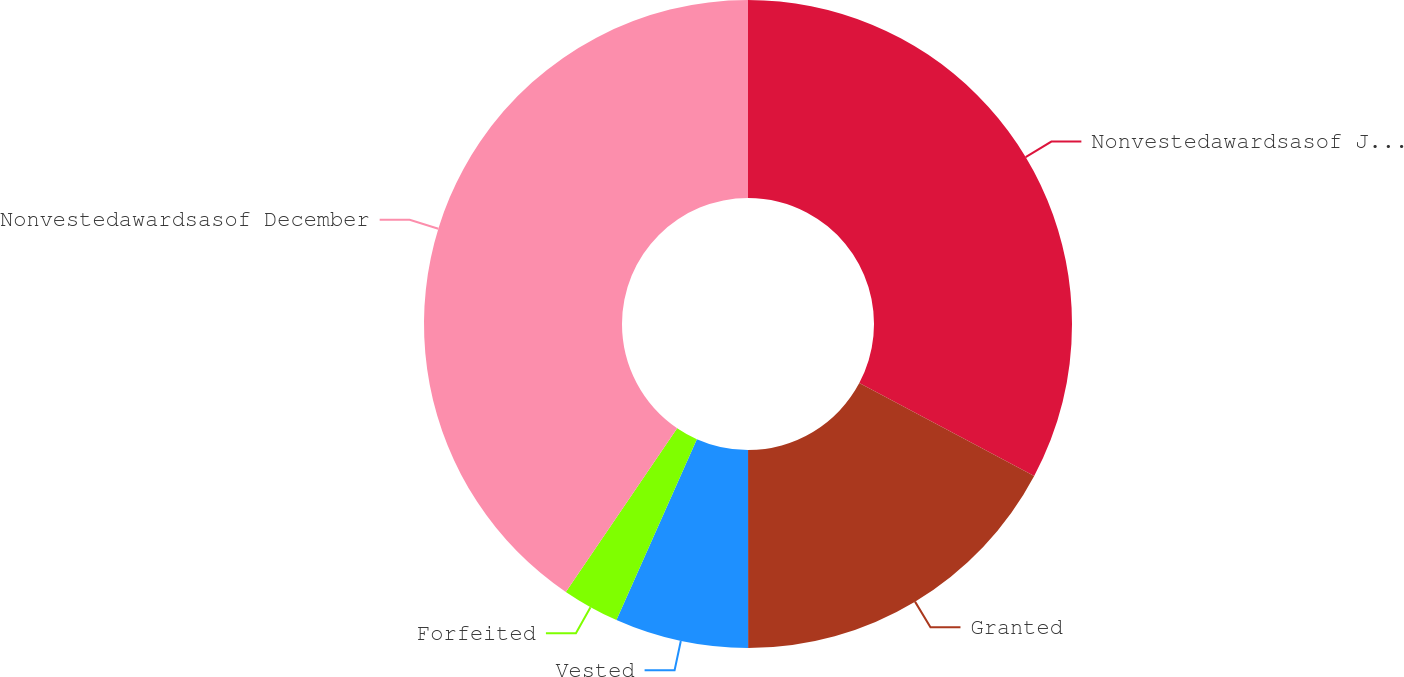Convert chart to OTSL. <chart><loc_0><loc_0><loc_500><loc_500><pie_chart><fcel>Nonvestedawardsasof January 1<fcel>Granted<fcel>Vested<fcel>Forfeited<fcel>Nonvestedawardsasof December<nl><fcel>32.77%<fcel>17.23%<fcel>6.66%<fcel>2.85%<fcel>40.5%<nl></chart> 